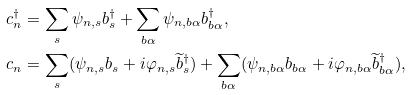<formula> <loc_0><loc_0><loc_500><loc_500>c ^ { \dag } _ { n } & = \sum _ { s } \psi _ { n , s } b ^ { \dag } _ { s } + \sum _ { b \alpha } \psi _ { n , b \alpha } b ^ { \dag } _ { b \alpha } , \\ c _ { n } & = \sum _ { s } ( \psi _ { n , s } b _ { s } + i \varphi _ { n , s } \widetilde { b } ^ { \dag } _ { s } ) + \sum _ { b \alpha } ( \psi _ { n , b \alpha } b _ { b \alpha } + i \varphi _ { n , b \alpha } \widetilde { b } ^ { \dag } _ { b \alpha } ) ,</formula> 